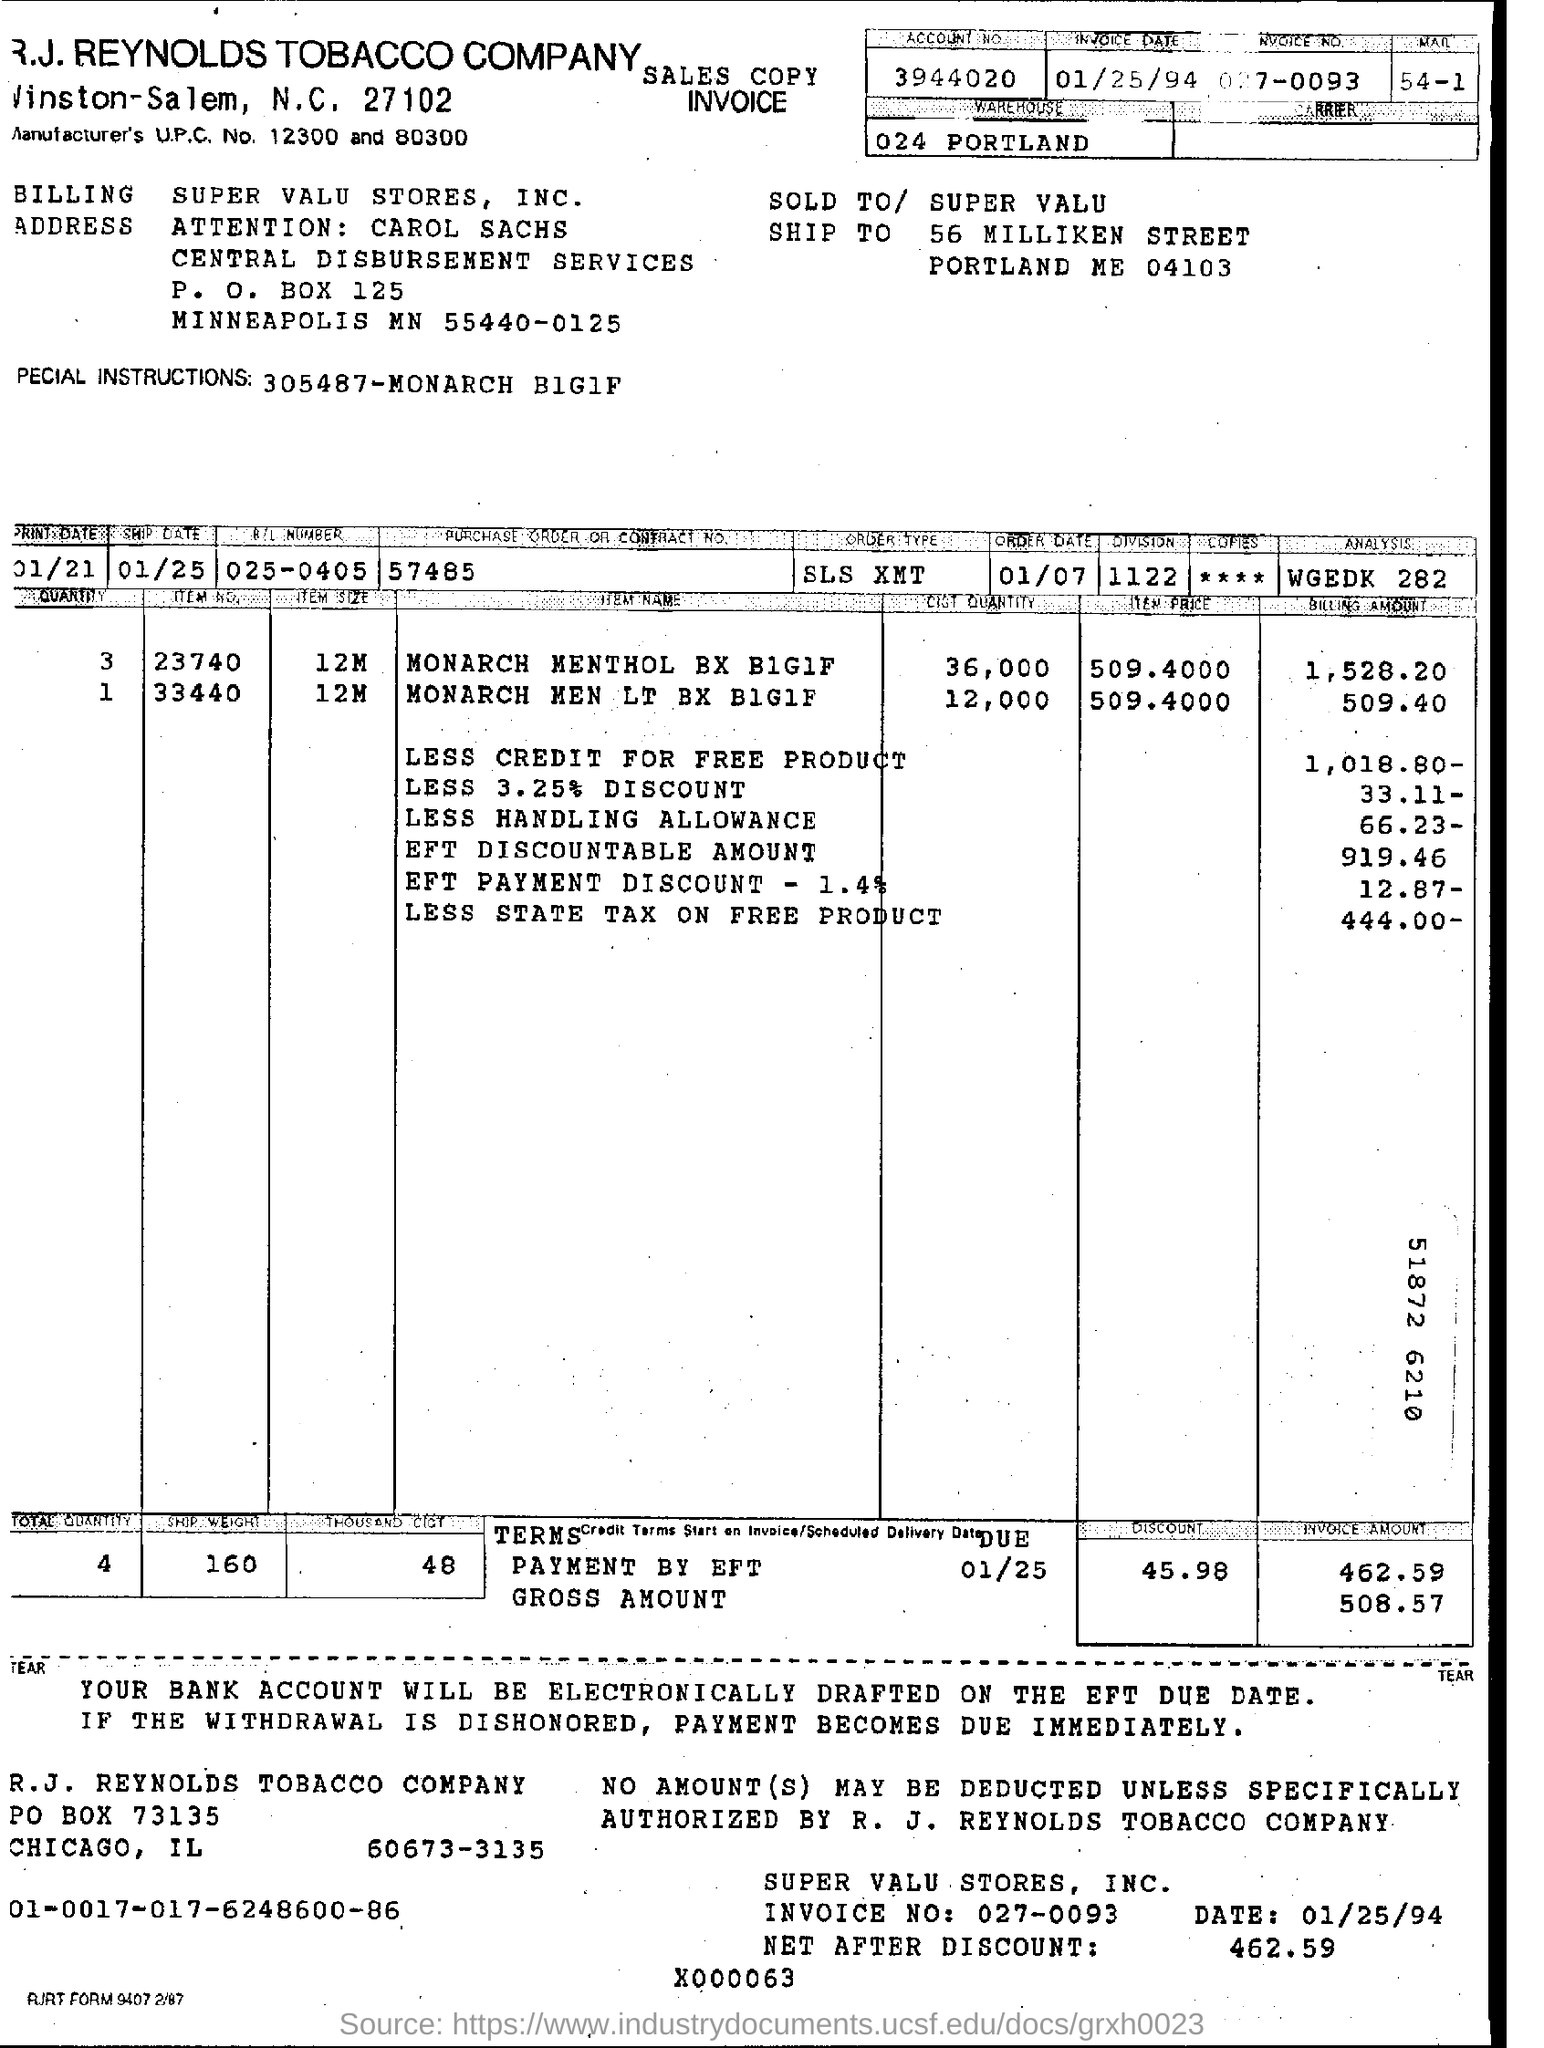Identify some key points in this picture. The invoice number is 027-0093. What is the P.O. box number of the billing address? It is 125. What is the size of item number 23740? It is 12 megabytes. The purchase order or contract number is 57485. The invoice date is January 25, 1994. 